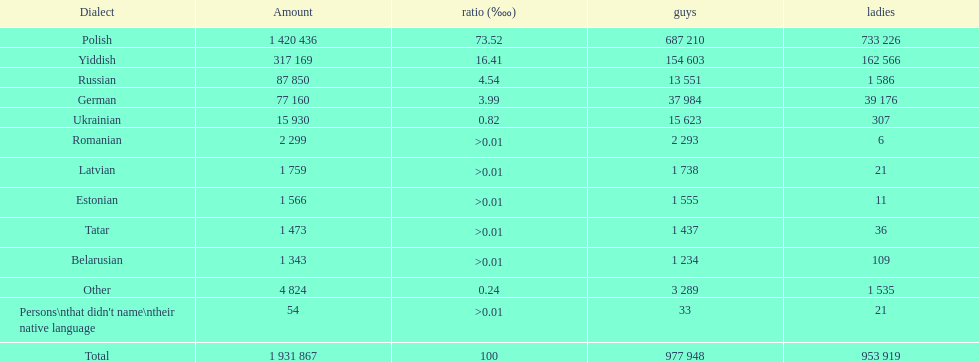The smallest number of women Romanian. Can you parse all the data within this table? {'header': ['Dialect', 'Amount', 'ratio (‱)', 'guys', 'ladies'], 'rows': [['Polish', '1 420 436', '73.52', '687 210', '733 226'], ['Yiddish', '317 169', '16.41', '154 603', '162 566'], ['Russian', '87 850', '4.54', '13 551', '1 586'], ['German', '77 160', '3.99', '37 984', '39 176'], ['Ukrainian', '15 930', '0.82', '15 623', '307'], ['Romanian', '2 299', '>0.01', '2 293', '6'], ['Latvian', '1 759', '>0.01', '1 738', '21'], ['Estonian', '1 566', '>0.01', '1 555', '11'], ['Tatar', '1 473', '>0.01', '1 437', '36'], ['Belarusian', '1 343', '>0.01', '1 234', '109'], ['Other', '4 824', '0.24', '3 289', '1 535'], ["Persons\\nthat didn't name\\ntheir native language", '54', '>0.01', '33', '21'], ['Total', '1 931 867', '100', '977 948', '953 919']]} 